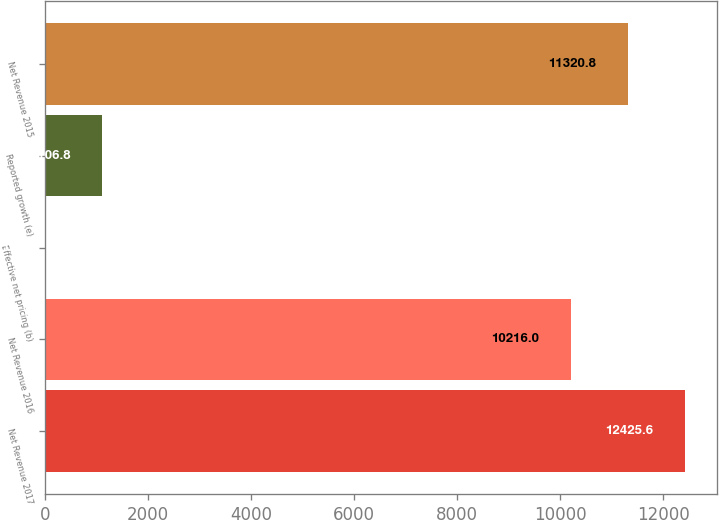<chart> <loc_0><loc_0><loc_500><loc_500><bar_chart><fcel>Net Revenue 2017<fcel>Net Revenue 2016<fcel>Effective net pricing (b)<fcel>Reported growth (e)<fcel>Net Revenue 2015<nl><fcel>12425.6<fcel>10216<fcel>2<fcel>1106.8<fcel>11320.8<nl></chart> 